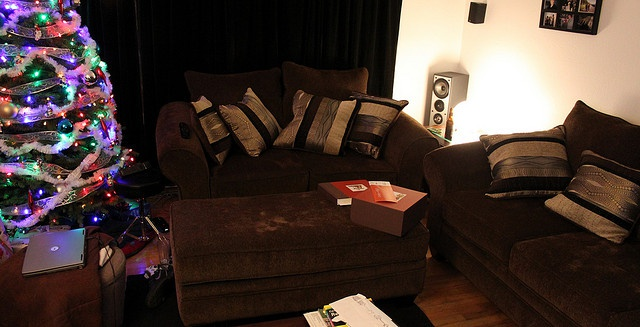Describe the objects in this image and their specific colors. I can see couch in magenta, black, maroon, and gray tones, couch in magenta, black, maroon, and brown tones, book in magenta, maroon, black, red, and brown tones, laptop in magenta, gray, purple, and black tones, and book in magenta, tan, black, and beige tones in this image. 